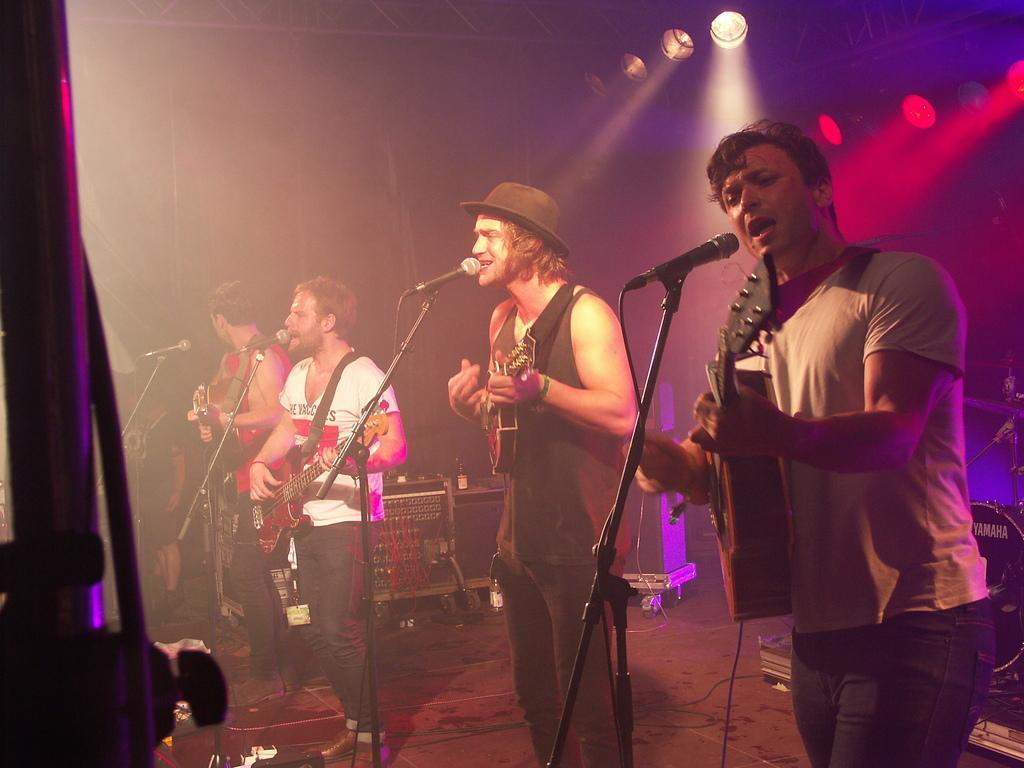How would you summarize this image in a sentence or two? Here we can see a group of people are standing, and playing guitar and singing, and in front here is the microphone and stand, and at back here are the lights. 